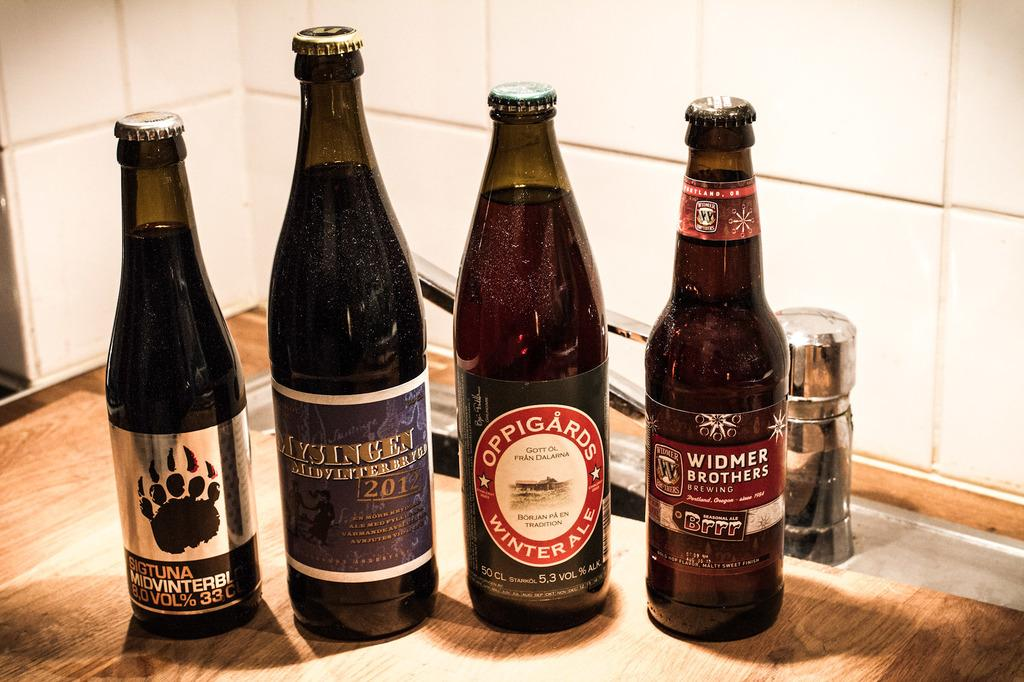<image>
Render a clear and concise summary of the photo. Four bottles of alcohol which includes a bottle by the Widmer Brothers. 